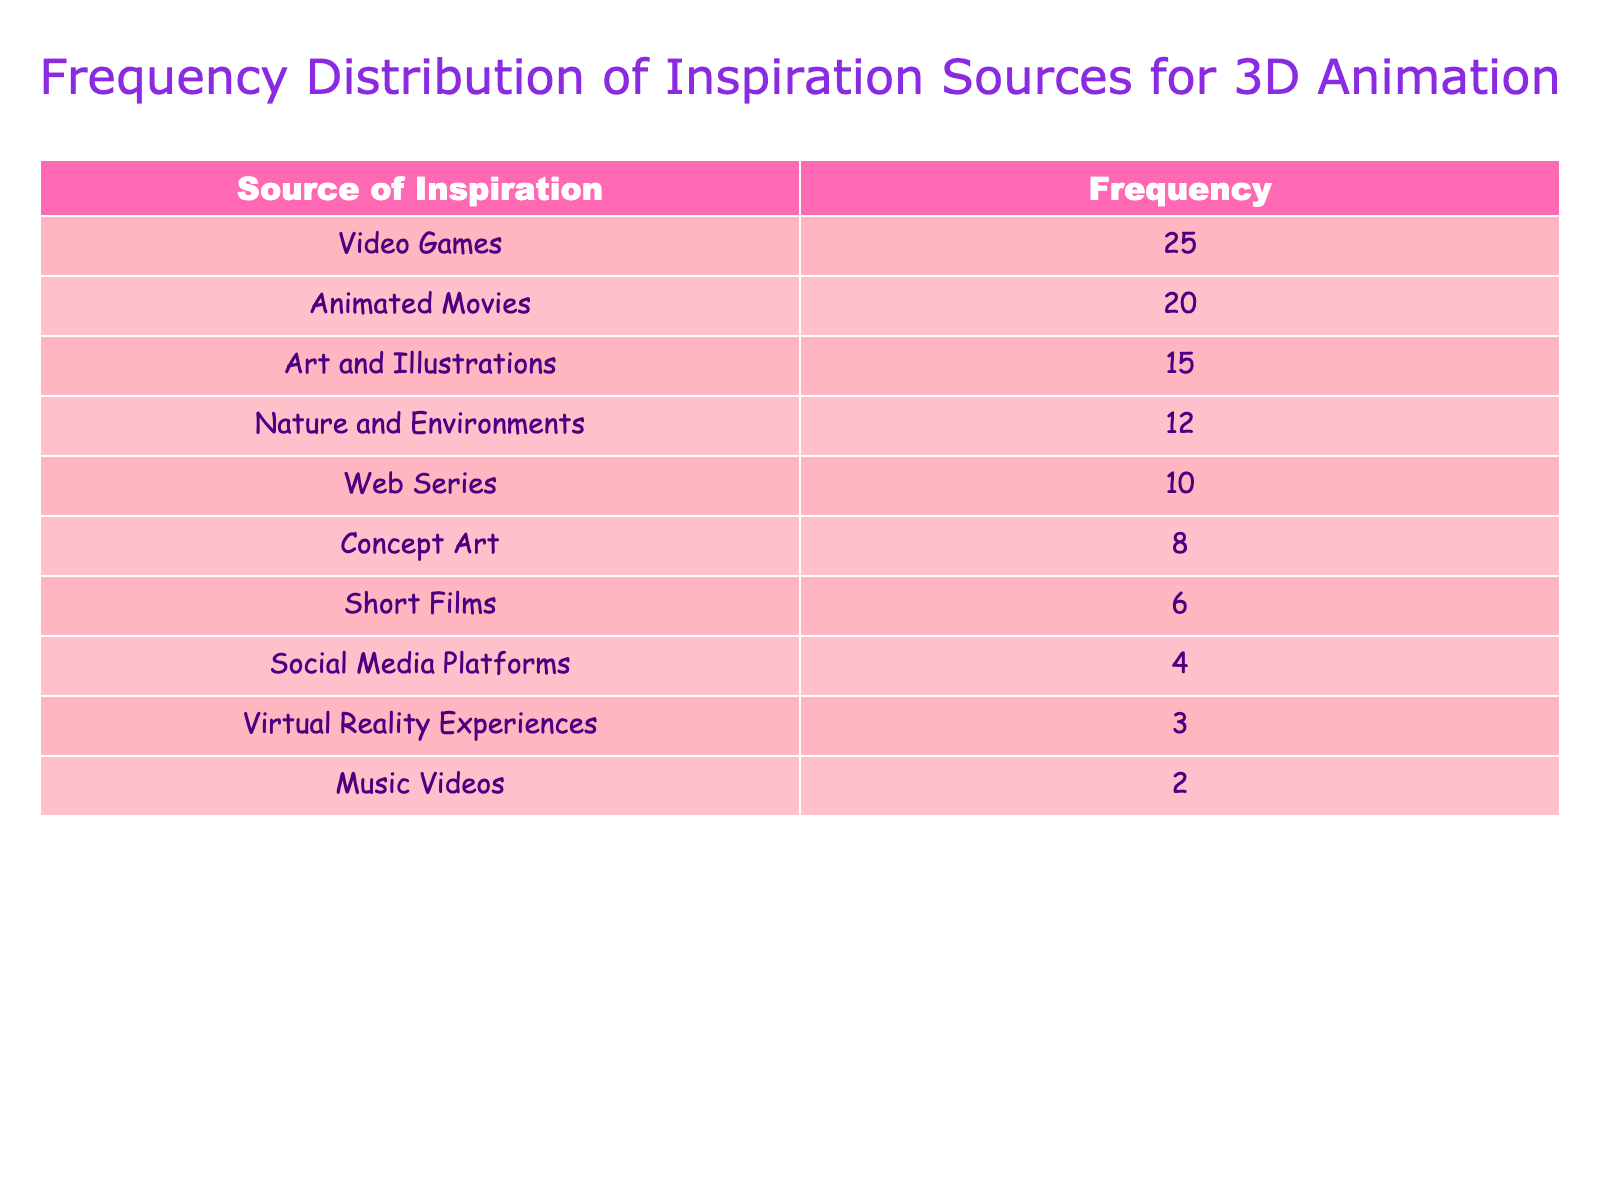What is the most common source of inspiration for 3D animation? The table lists the sources of inspiration along with their frequencies. The source with the highest frequency is "Video Games," which has a frequency of 25.
Answer: Video Games How many sources of inspiration have a frequency of 10 or more? Looking at the frequency column, we can count how many sources have values of 10 or more. Those sources are: Video Games (25), Animated Movies (20), Art and Illustrations (15), Nature and Environments (12), and Web Series (10). This gives us a total of 5 sources.
Answer: 5 What is the total frequency of inspiration from "Nature and Environments" and "Animated Movies"? To find the total frequency, we look up the values for these two specific sources. "Animated Movies" has a frequency of 20, and "Nature and Environments" has a frequency of 12. We sum these: 20 + 12 = 32.
Answer: 32 Is "Social Media Platforms" the least common source of inspiration? We can scan the frequency values to determine if "Social Media Platforms" is the least common. Its frequency is 4, while all other sources have higher frequencies. There are two sources with lower frequencies, namely "Virtual Reality Experiences" (3) and "Music Videos" (2). Thus, the statement is false.
Answer: No What is the difference in frequency between the most and the least common sources of inspiration? The most common source is "Video Games" with a frequency of 25, and the least common source is "Music Videos" with a frequency of 2. The difference is calculated as 25 - 2, resulting in 23.
Answer: 23 How many less frequent sources of inspiration have a frequency below 5? To answer this, we check the sources and their frequencies. The sources below 5 are "Virtual Reality Experiences" (3) and "Music Videos" (2), giving us a total of 2 sources.
Answer: 2 What is the average frequency of all sources of inspiration? To find the average, we first calculate the total frequency by summing all the values: 25 + 20 + 15 + 12 + 10 + 8 + 6 + 4 + 3 + 2 = 105. Then, we divide this total by the number of sources, which is 10. Therefore, the average is 105 / 10 = 10.5.
Answer: 10.5 Which sources of inspiration have a frequency greater than 15? By examining the table, the sources with a frequency greater than 15 are "Video Games" (25) and "Animated Movies" (20). Thus, there are 2 sources.
Answer: 2 Is the frequency of "Short Films" more than that of "Concept Art"? "Short Films" has a frequency of 6, whereas "Concept Art" has a frequency of 8. Since 6 is not more than 8, the statement is false.
Answer: No 